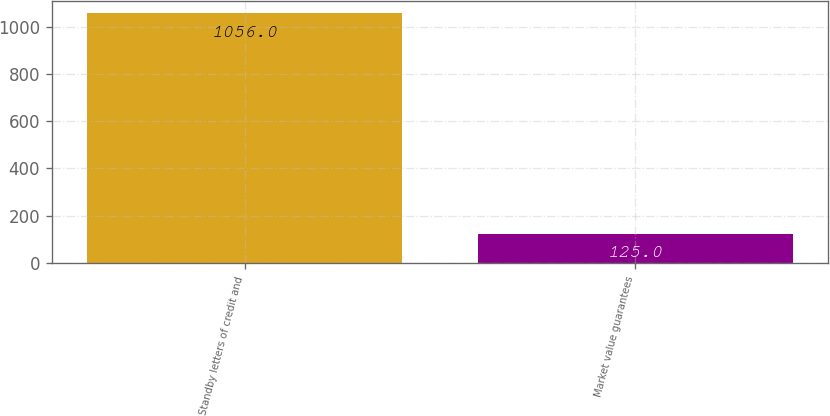Convert chart. <chart><loc_0><loc_0><loc_500><loc_500><bar_chart><fcel>Standby letters of credit and<fcel>Market value guarantees<nl><fcel>1056<fcel>125<nl></chart> 